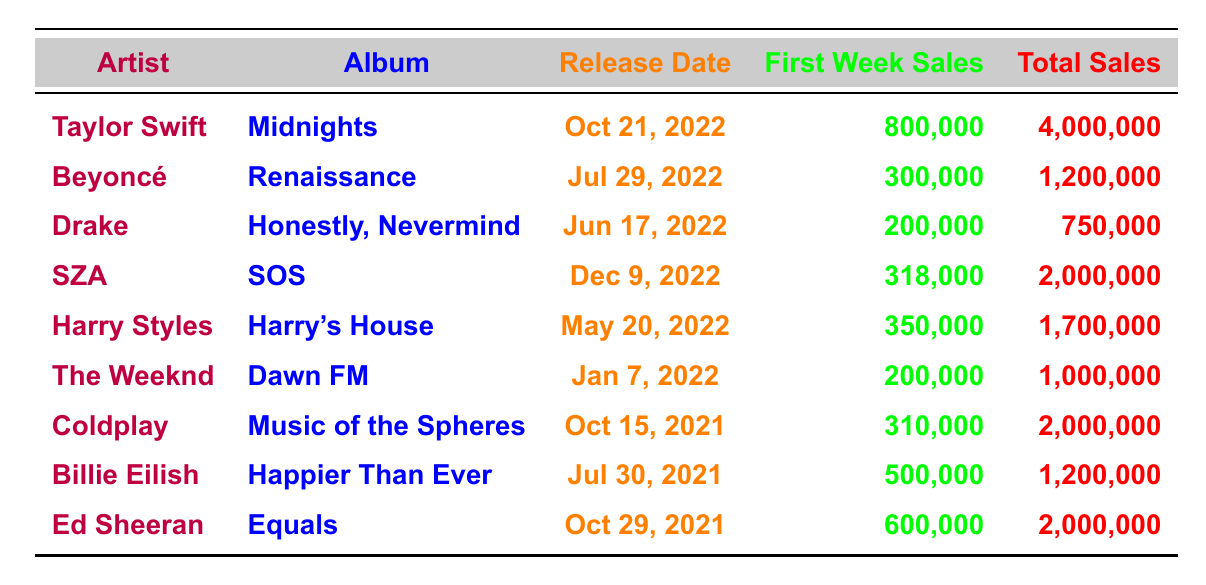What is the total sales figure for Taylor Swift's album? The table shows that Taylor Swift's album "Midnights" has total sales of 4,000,000.
Answer: 4,000,000 Which artist had the highest first week sales in this table? Taylor Swift had the highest first week sales with 800,000.
Answer: Taylor Swift What is the average total sales for all artists in the table? Summing the total sales: 4,000,000 + 1,200,000 + 750,000 + 2,000,000 + 1,700,000 + 1,000,000 + 2,000,000 + 1,200,000 + 2,000,000 = 15,850,000 and there are 9 artists, so the average is 15,850,000 / 9 ≈ 1,761,111.11.
Answer: 1,761,111.11 Is SZA's album "SOS" performing better than Drake's album in total sales? SZA's total sales are 2,000,000 while Drake's total sales are 750,000. Since 2,000,000 is greater than 750,000, the statement is true.
Answer: Yes How much higher are Taylor Swift's first week sales compared to Beyoncé's? Taylor Swift's first week sales are 800,000 and Beyoncé's are 300,000. Subtracting gives 800,000 - 300,000 = 500,000.
Answer: 500,000 Which artist's album has the earliest release date in the table? The earliest release date listed is January 7, 2022, from The Weeknd's album "Dawn FM".
Answer: The Weeknd If you combine the total sales of Ed Sheeran and Billie Eilish, what is the result? Ed Sheeran's total sales are 2,000,000 and Billie Eilish's are 1,200,000. Adding these gives 2,000,000 + 1,200,000 = 3,200,000.
Answer: 3,200,000 Are total sales figures for Coldplay’s album equal to the total sales figures for SZA’s album? Coldplay's total sales are 2,000,000 and SZA's are also 2,000,000, so they are equal.
Answer: Yes Which artist sold fewer albums overall, Drake or Harry Styles? Drake's total sales are 750,000 while Harry Styles's total sales are 1,700,000. Since 750,000 is less than 1,700,000, Drake sold fewer albums.
Answer: Drake What is the difference in first week sales between "Harry's House" and "Music of the Spheres"? "Harry's House" had first week sales of 350,000 and "Music of the Spheres" had 310,000. The difference is 350,000 - 310,000 = 40,000.
Answer: 40,000 